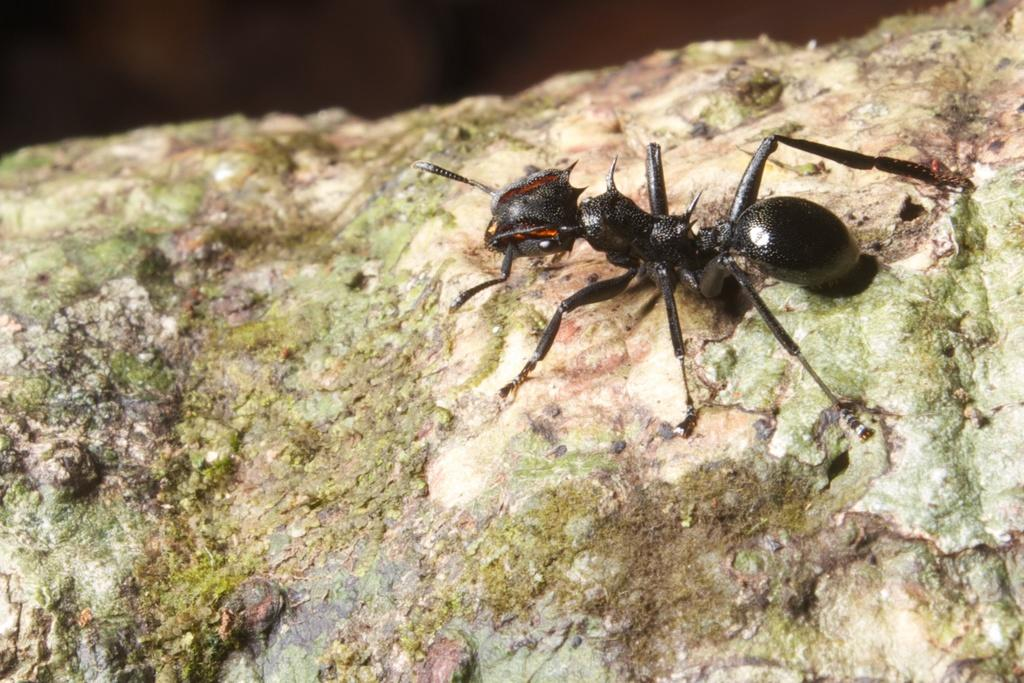What type of insect is in the picture? There is a black ant in the picture. Can you describe the anatomy of the ant? The ant has legs, a head, and a body. What other object is present in the picture? There is a stone in the picture. How does the ant interact with the loaf in the picture? There is no loaf present in the picture; it only features a black ant and a stone. 